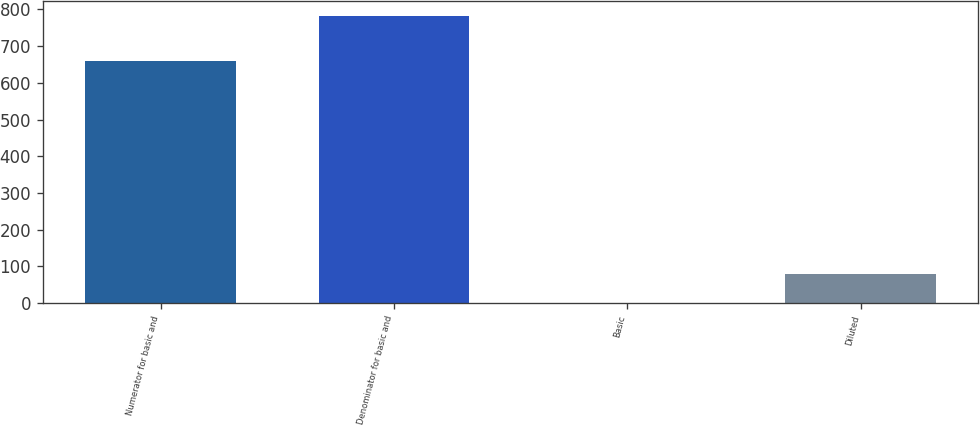Convert chart. <chart><loc_0><loc_0><loc_500><loc_500><bar_chart><fcel>Numerator for basic and<fcel>Denominator for basic and<fcel>Basic<fcel>Diluted<nl><fcel>660<fcel>783<fcel>0.84<fcel>79.06<nl></chart> 